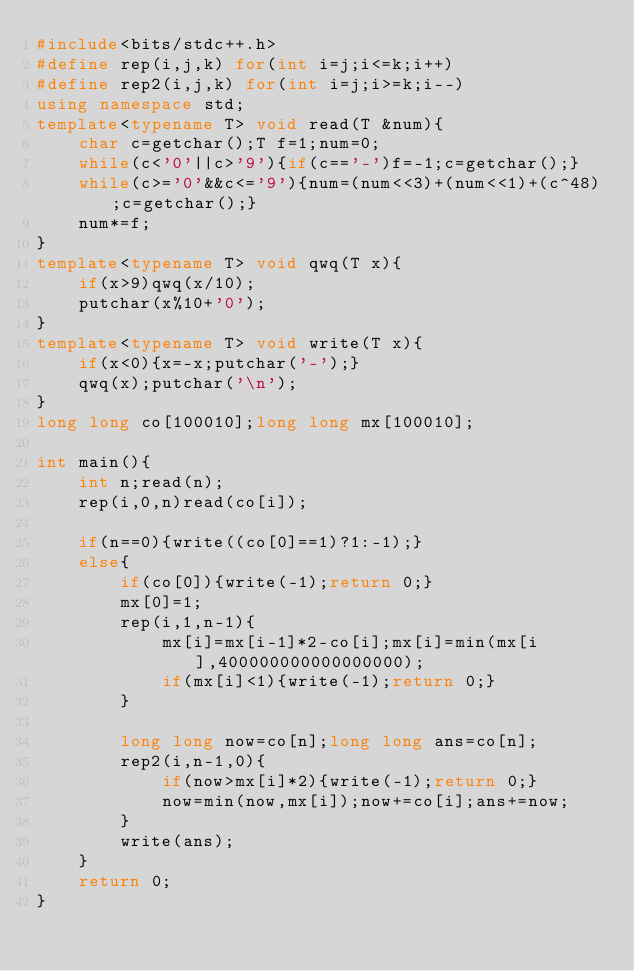<code> <loc_0><loc_0><loc_500><loc_500><_C++_>#include<bits/stdc++.h>
#define rep(i,j,k) for(int i=j;i<=k;i++)
#define rep2(i,j,k) for(int i=j;i>=k;i--)
using namespace std;
template<typename T> void read(T &num){
	char c=getchar();T f=1;num=0;
	while(c<'0'||c>'9'){if(c=='-')f=-1;c=getchar();}
	while(c>='0'&&c<='9'){num=(num<<3)+(num<<1)+(c^48);c=getchar();}
	num*=f;
}
template<typename T> void qwq(T x){
	if(x>9)qwq(x/10);
	putchar(x%10+'0');
}
template<typename T> void write(T x){
	if(x<0){x=-x;putchar('-');}
	qwq(x);putchar('\n');
}
long long co[100010];long long mx[100010];

int main(){
	int n;read(n);
	rep(i,0,n)read(co[i]);
	
	if(n==0){write((co[0]==1)?1:-1);}
	else{
		if(co[0]){write(-1);return 0;}
		mx[0]=1;
		rep(i,1,n-1){
			mx[i]=mx[i-1]*2-co[i];mx[i]=min(mx[i],400000000000000000);
			if(mx[i]<1){write(-1);return 0;}
		}
		
		long long now=co[n];long long ans=co[n];
		rep2(i,n-1,0){
			if(now>mx[i]*2){write(-1);return 0;}
			now=min(now,mx[i]);now+=co[i];ans+=now;	
		}
		write(ans);
	}
	return 0;
}</code> 